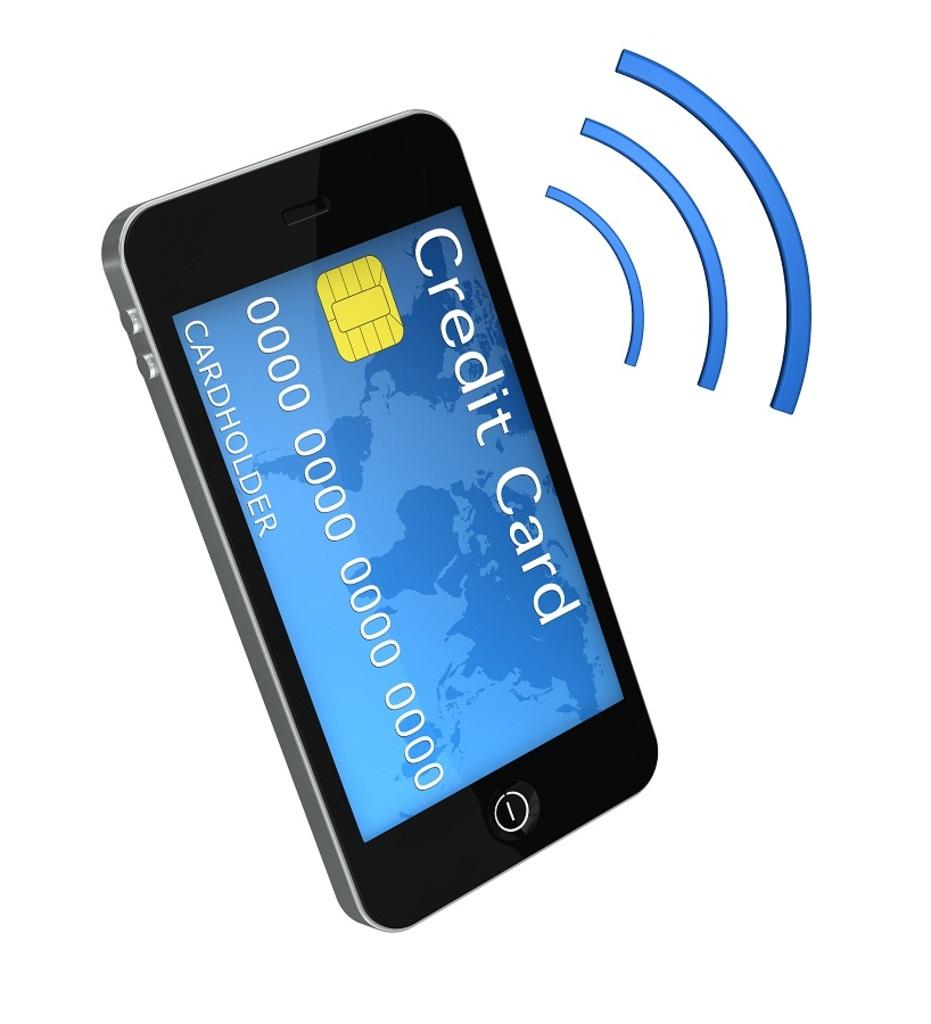What object is located on the left side of the image? There is a mobile on the left side of the image. What feature does the mobile have? The mobile has a screen. What can be seen on the right side of the image? There are three blue color curved lines on the right side of the image. What color is the background of the image? The background of the image is white. What scent can be detected from the mobile in the image? There is no mention of a scent in the image, and therefore it cannot be detected. 